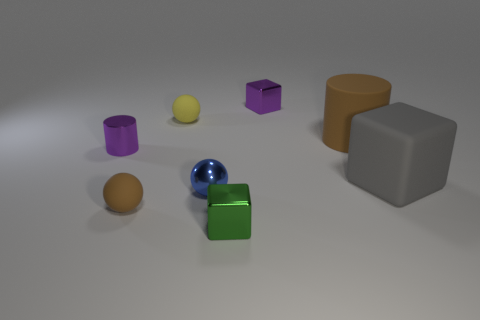Add 2 green cubes. How many objects exist? 10 Subtract all cylinders. How many objects are left? 6 Subtract all small spheres. Subtract all matte spheres. How many objects are left? 3 Add 7 blue balls. How many blue balls are left? 8 Add 8 green metallic blocks. How many green metallic blocks exist? 9 Subtract 1 brown cylinders. How many objects are left? 7 